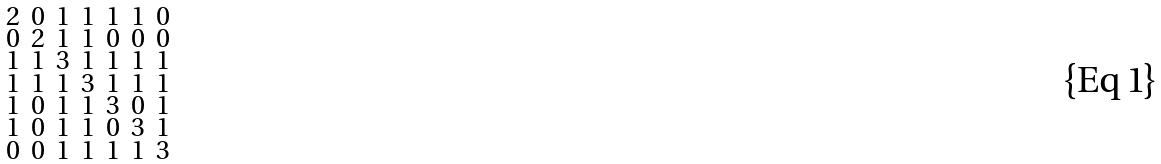<formula> <loc_0><loc_0><loc_500><loc_500>\begin{smallmatrix} 2 & 0 & 1 & 1 & 1 & 1 & 0 \\ 0 & 2 & 1 & 1 & 0 & 0 & 0 \\ 1 & 1 & 3 & 1 & 1 & 1 & 1 \\ 1 & 1 & 1 & 3 & 1 & 1 & 1 \\ 1 & 0 & 1 & 1 & 3 & 0 & 1 \\ 1 & 0 & 1 & 1 & 0 & 3 & 1 \\ 0 & 0 & 1 & 1 & 1 & 1 & 3 \end{smallmatrix}</formula> 